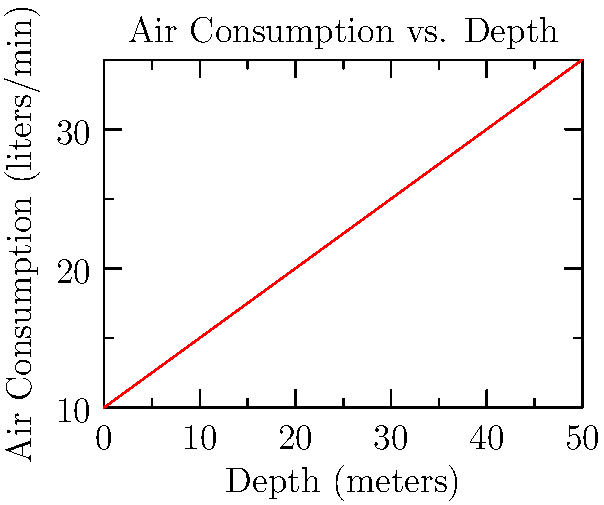A scuba diver's air consumption rate increases with depth due to increased pressure. The graph shows the relationship between depth and air consumption rate. If the diver descends from 20 meters to 40 meters over a period of 10 minutes, what is the average rate of change in air consumption during this descent? To solve this problem, we need to follow these steps:

1. Identify the air consumption rates at 20 meters and 40 meters depths:
   At 20 meters: $20$ liters/min
   At 40 meters: $30$ liters/min

2. Calculate the change in air consumption:
   $\Delta y = 30 - 20 = 10$ liters/min

3. Calculate the change in depth:
   $\Delta x = 40 - 20 = 20$ meters

4. Use the average rate of change formula:
   Average rate of change = $\frac{\Delta y}{\Delta x}$

5. Substitute the values:
   Average rate of change = $\frac{10 \text{ liters/min}}{20 \text{ meters}} = 0.5$ liters/min per meter

Therefore, the average rate of change in air consumption is 0.5 liters/min per meter of depth increase.
Answer: $0.5$ liters/min per meter 